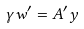Convert formula to latex. <formula><loc_0><loc_0><loc_500><loc_500>\gamma w ^ { \prime } = A ^ { \prime } y</formula> 